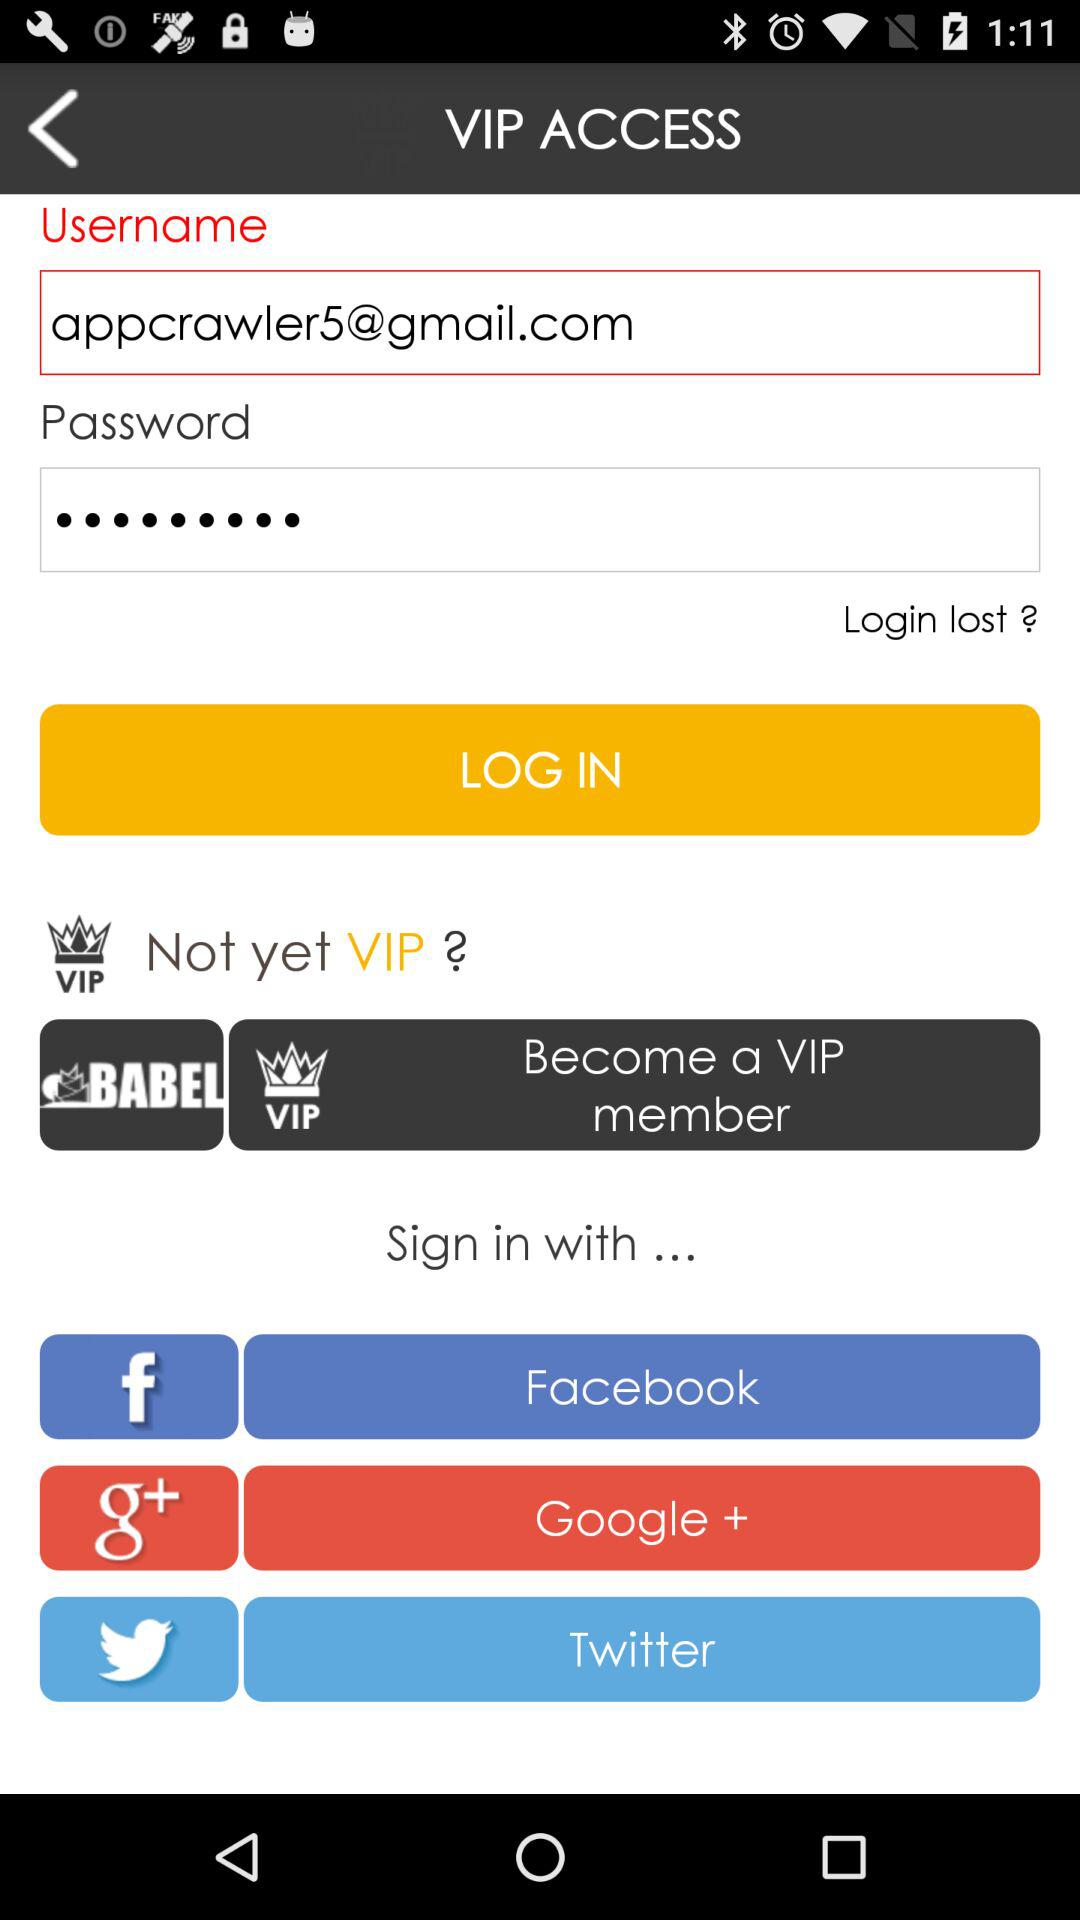What are the names of the different accounts through which signing in can be done? The names of the different accounts through which signing in can be done are "Facebook", "Google +" and "Twitter". 